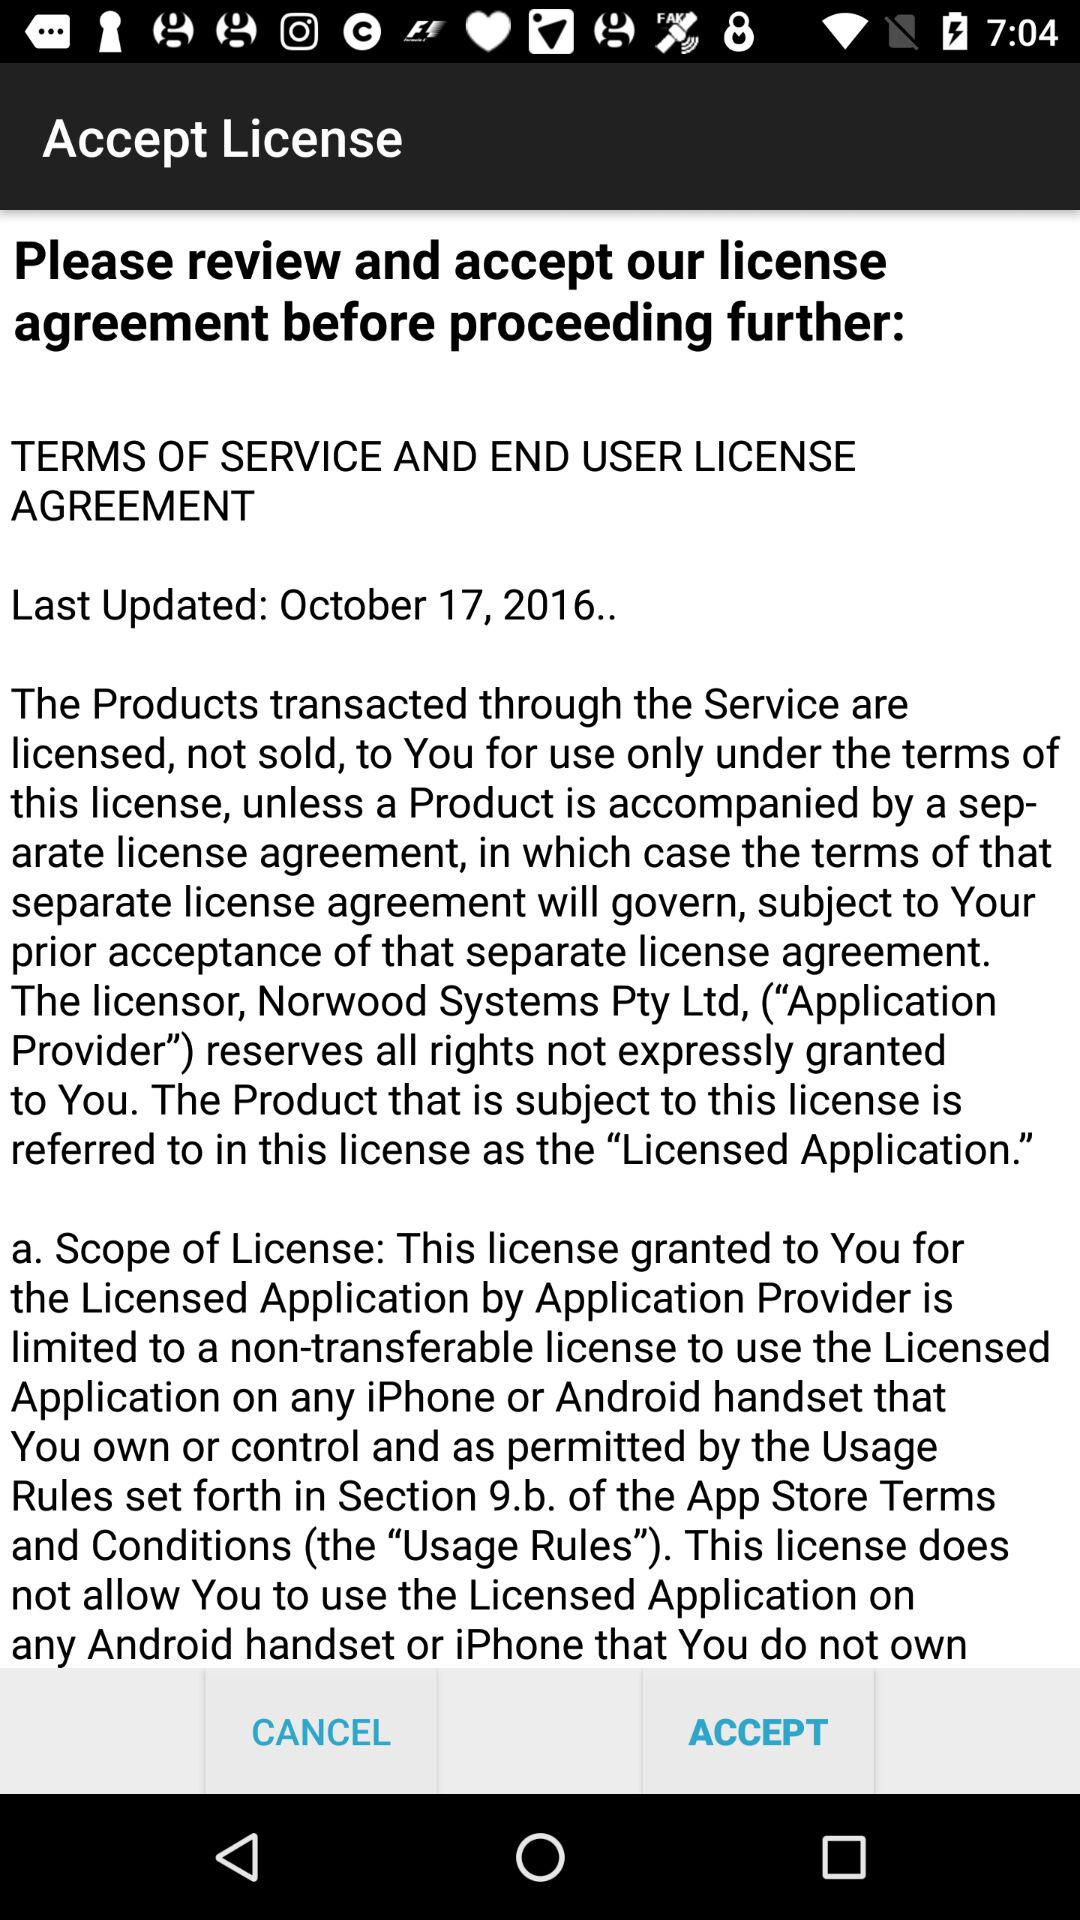When was the latest update done? It was last updated on October 17, 2016. 